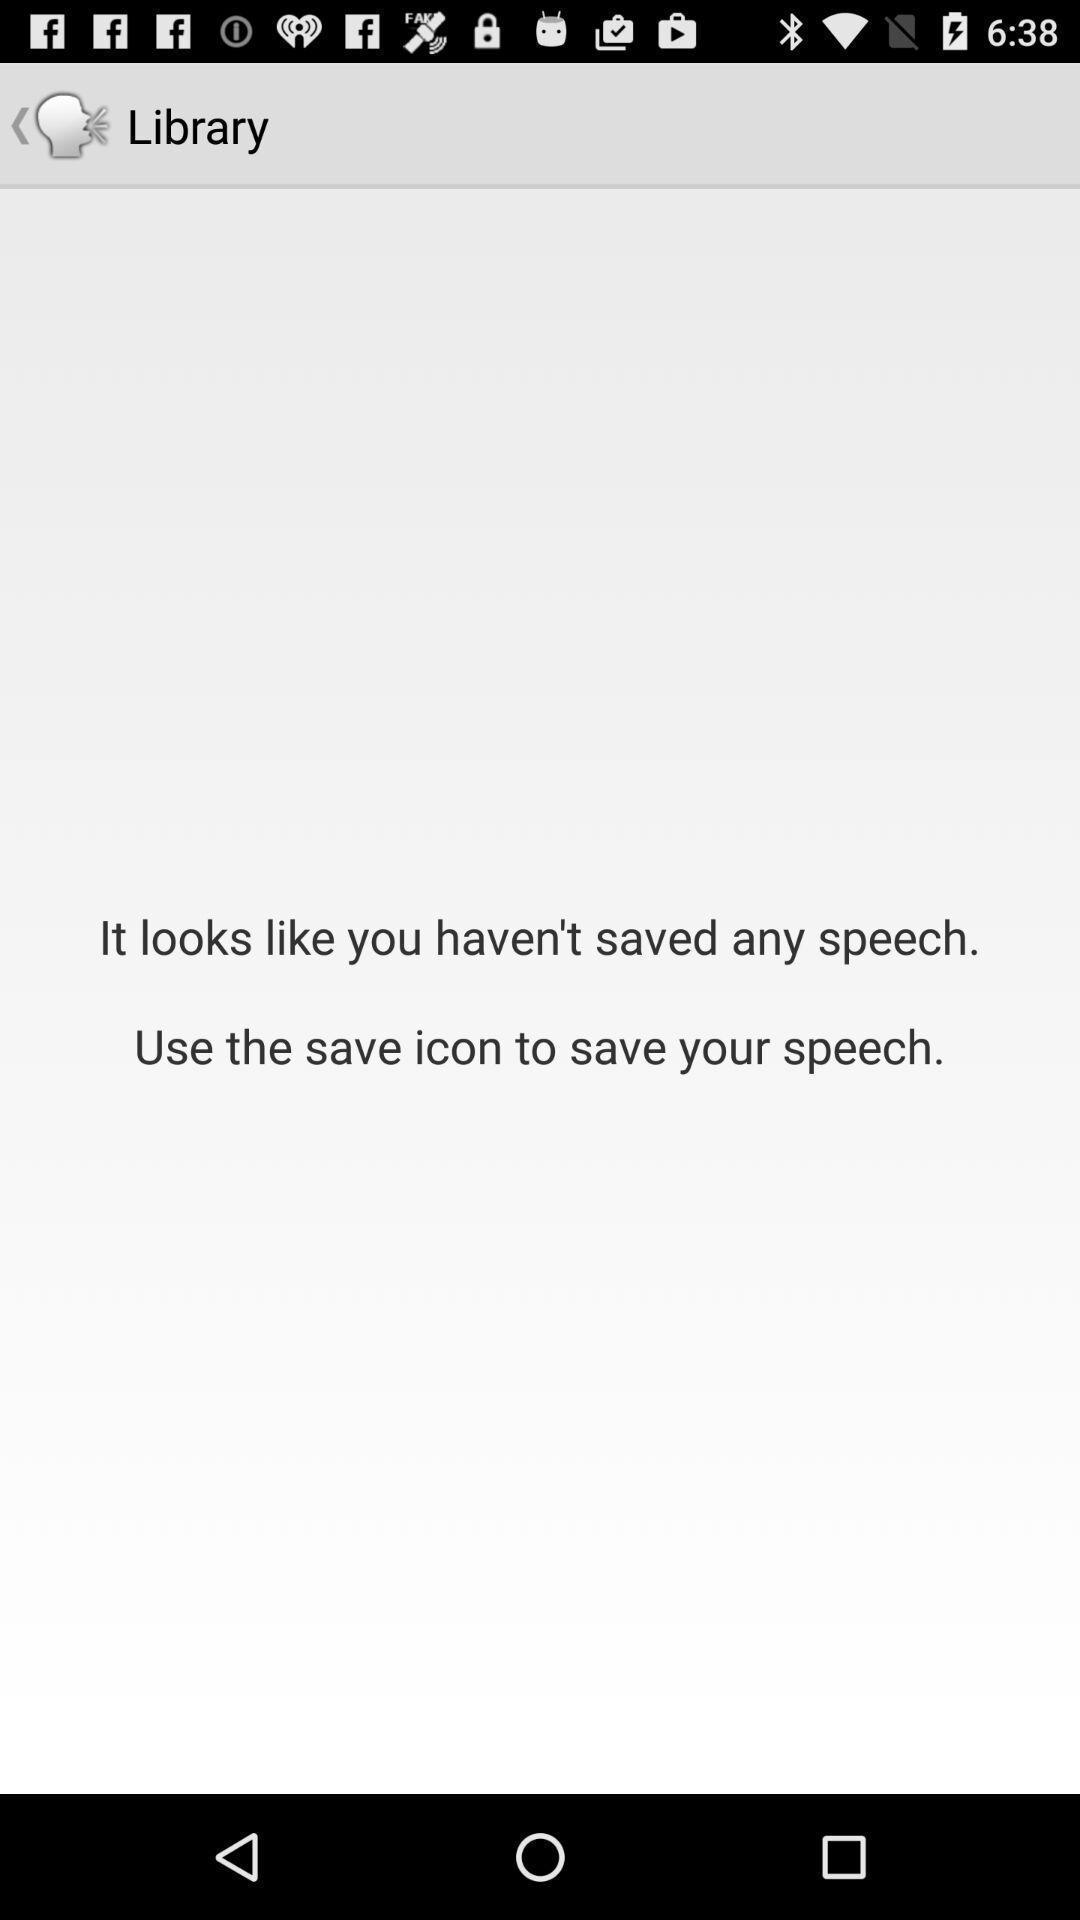Explain what's happening in this screen capture. Screen displaying the empty page in library tab. 